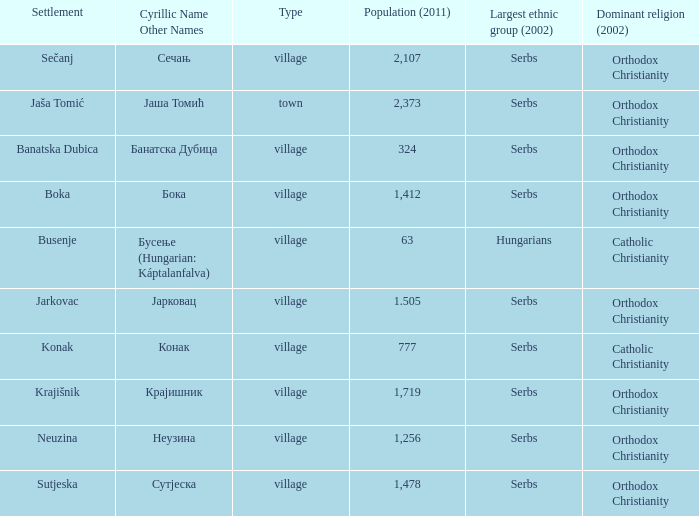What is the ethnic group is конак? Serbs. 